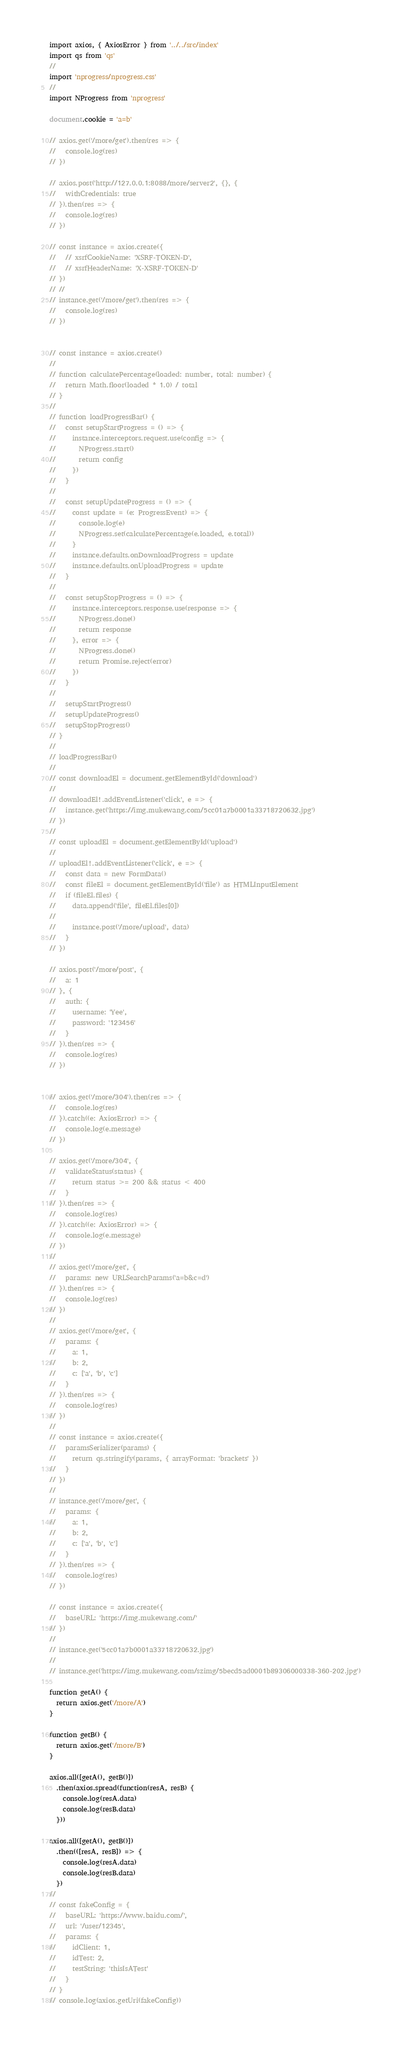<code> <loc_0><loc_0><loc_500><loc_500><_TypeScript_>import axios, { AxiosError } from '../../src/index'
import qs from 'qs'
//
import 'nprogress/nprogress.css'
//
import NProgress from 'nprogress'

document.cookie = 'a=b'

// axios.get('/more/get').then(res => {
//   console.log(res)
// })

// axios.post('http://127.0.0.1:8088/more/server2', {}, {
//   withCredentials: true
// }).then(res => {
//   console.log(res)
// })

// const instance = axios.create({
//   // xsrfCookieName: 'XSRF-TOKEN-D',
//   // xsrfHeaderName: 'X-XSRF-TOKEN-D'
// })
// //
// instance.get('/more/get').then(res => {
//   console.log(res)
// })


// const instance = axios.create()
//
// function calculatePercentage(loaded: number, total: number) {
//   return Math.floor(loaded * 1.0) / total
// }
//
// function loadProgressBar() {
//   const setupStartProgress = () => {
//     instance.interceptors.request.use(config => {
//       NProgress.start()
//       return config
//     })
//   }
//
//   const setupUpdateProgress = () => {
//     const update = (e: ProgressEvent) => {
//       console.log(e)
//       NProgress.set(calculatePercentage(e.loaded, e.total))
//     }
//     instance.defaults.onDownloadProgress = update
//     instance.defaults.onUploadProgress = update
//   }
//
//   const setupStopProgress = () => {
//     instance.interceptors.response.use(response => {
//       NProgress.done()
//       return response
//     }, error => {
//       NProgress.done()
//       return Promise.reject(error)
//     })
//   }
//
//   setupStartProgress()
//   setupUpdateProgress()
//   setupStopProgress()
// }
//
// loadProgressBar()
//
// const downloadEl = document.getElementById('download')
//
// downloadEl!.addEventListener('click', e => {
//   instance.get('https://img.mukewang.com/5cc01a7b0001a33718720632.jpg')
// })
//
// const uploadEl = document.getElementById('upload')
//
// uploadEl!.addEventListener('click', e => {
//   const data = new FormData()
//   const fileEl = document.getElementById('file') as HTMLInputElement
//   if (fileEl.files) {
//     data.append('file', fileEl.files[0])
//
//     instance.post('/more/upload', data)
//   }
// })

// axios.post('/more/post', {
//   a: 1
// }, {
//   auth: {
//     username: 'Yee',
//     password: '123456'
//   }
// }).then(res => {
//   console.log(res)
// })


// axios.get('/more/304').then(res => {
//   console.log(res)
// }).catch((e: AxiosError) => {
//   console.log(e.message)
// })

// axios.get('/more/304', {
//   validateStatus(status) {
//     return status >= 200 && status < 400
//   }
// }).then(res => {
//   console.log(res)
// }).catch((e: AxiosError) => {
//   console.log(e.message)
// })
//
// axios.get('/more/get', {
//   params: new URLSearchParams('a=b&c=d')
// }).then(res => {
//   console.log(res)
// })
//
// axios.get('/more/get', {
//   params: {
//     a: 1,
//     b: 2,
//     c: ['a', 'b', 'c']
//   }
// }).then(res => {
//   console.log(res)
// })
//
// const instance = axios.create({
//   paramsSerializer(params) {
//     return qs.stringify(params, { arrayFormat: 'brackets' })
//   }
// })
//
// instance.get('/more/get', {
//   params: {
//     a: 1,
//     b: 2,
//     c: ['a', 'b', 'c']
//   }
// }).then(res => {
//   console.log(res)
// })

// const instance = axios.create({
//   baseURL: 'https://img.mukewang.com/'
// })
//
// instance.get('5cc01a7b0001a33718720632.jpg')
//
// instance.get('https://img.mukewang.com/szimg/5becd5ad0001b89306000338-360-202.jpg')

function getA() {
  return axios.get('/more/A')
}

function getB() {
  return axios.get('/more/B')
}

axios.all([getA(), getB()])
  .then(axios.spread(function(resA, resB) {
    console.log(resA.data)
    console.log(resB.data)
  }))

axios.all([getA(), getB()])
  .then(([resA, resB]) => {
    console.log(resA.data)
    console.log(resB.data)
  })
//
// const fakeConfig = {
//   baseURL: 'https://www.baidu.com/',
//   url: '/user/12345',
//   params: {
//     idClient: 1,
//     idTest: 2,
//     testString: 'thisIsATest'
//   }
// }
// console.log(axios.getUri(fakeConfig))
</code> 